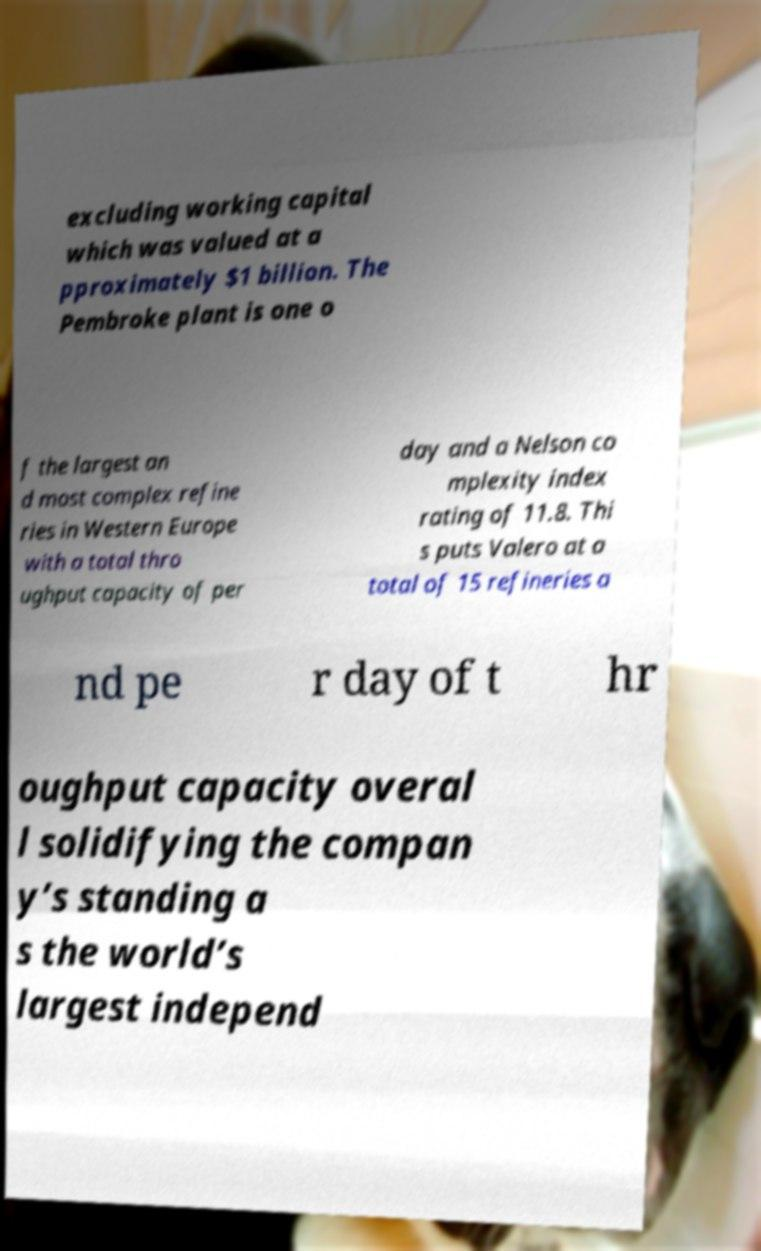Could you extract and type out the text from this image? excluding working capital which was valued at a pproximately $1 billion. The Pembroke plant is one o f the largest an d most complex refine ries in Western Europe with a total thro ughput capacity of per day and a Nelson co mplexity index rating of 11.8. Thi s puts Valero at a total of 15 refineries a nd pe r day of t hr oughput capacity overal l solidifying the compan y’s standing a s the world’s largest independ 